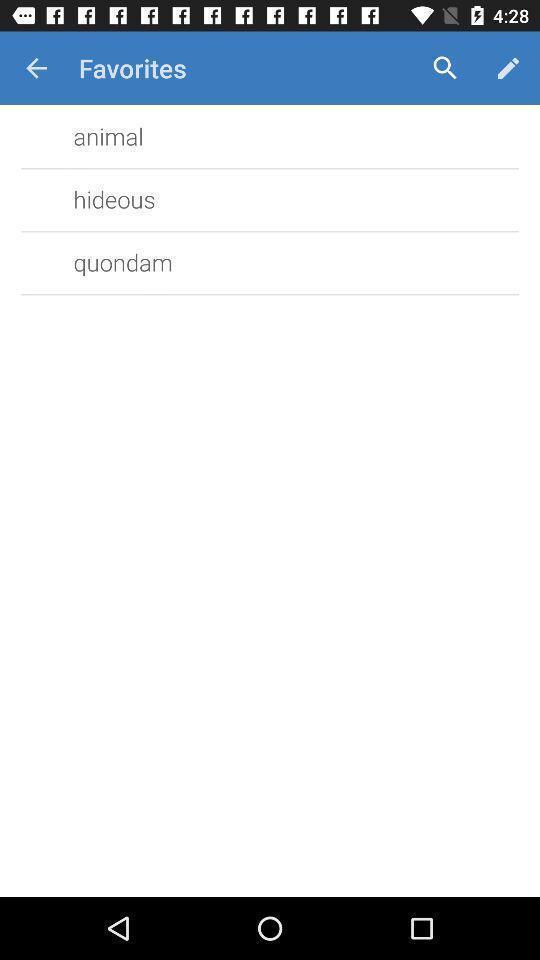Explain the elements present in this screenshot. Page displaying data with search and edit options in application. 